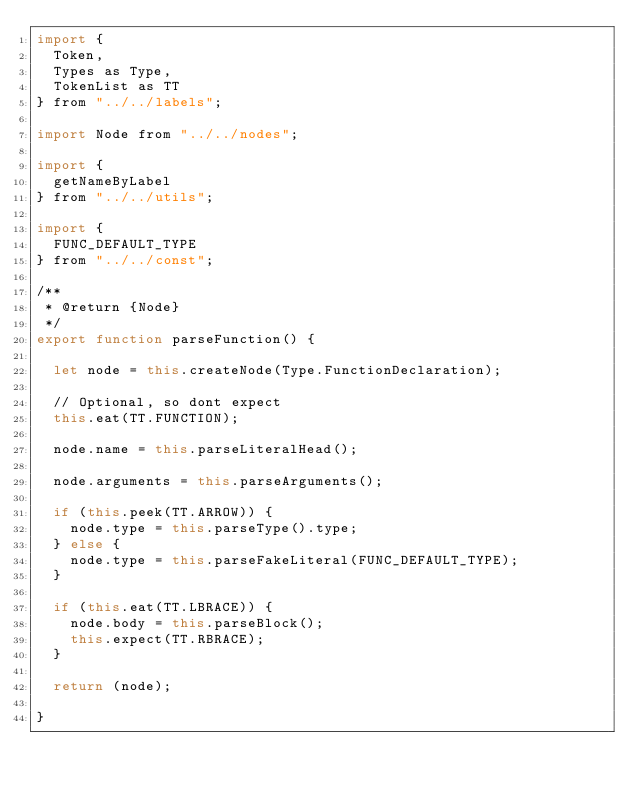<code> <loc_0><loc_0><loc_500><loc_500><_JavaScript_>import {
  Token,
  Types as Type,
  TokenList as TT
} from "../../labels";

import Node from "../../nodes";

import {
  getNameByLabel
} from "../../utils";

import {
  FUNC_DEFAULT_TYPE
} from "../../const";

/**
 * @return {Node}
 */
export function parseFunction() {

  let node = this.createNode(Type.FunctionDeclaration);

  // Optional, so dont expect
  this.eat(TT.FUNCTION);

  node.name = this.parseLiteralHead();

  node.arguments = this.parseArguments();

  if (this.peek(TT.ARROW)) {
    node.type = this.parseType().type;
  } else {
    node.type = this.parseFakeLiteral(FUNC_DEFAULT_TYPE);
  }

  if (this.eat(TT.LBRACE)) {
    node.body = this.parseBlock();
    this.expect(TT.RBRACE);
  }

  return (node);

}</code> 